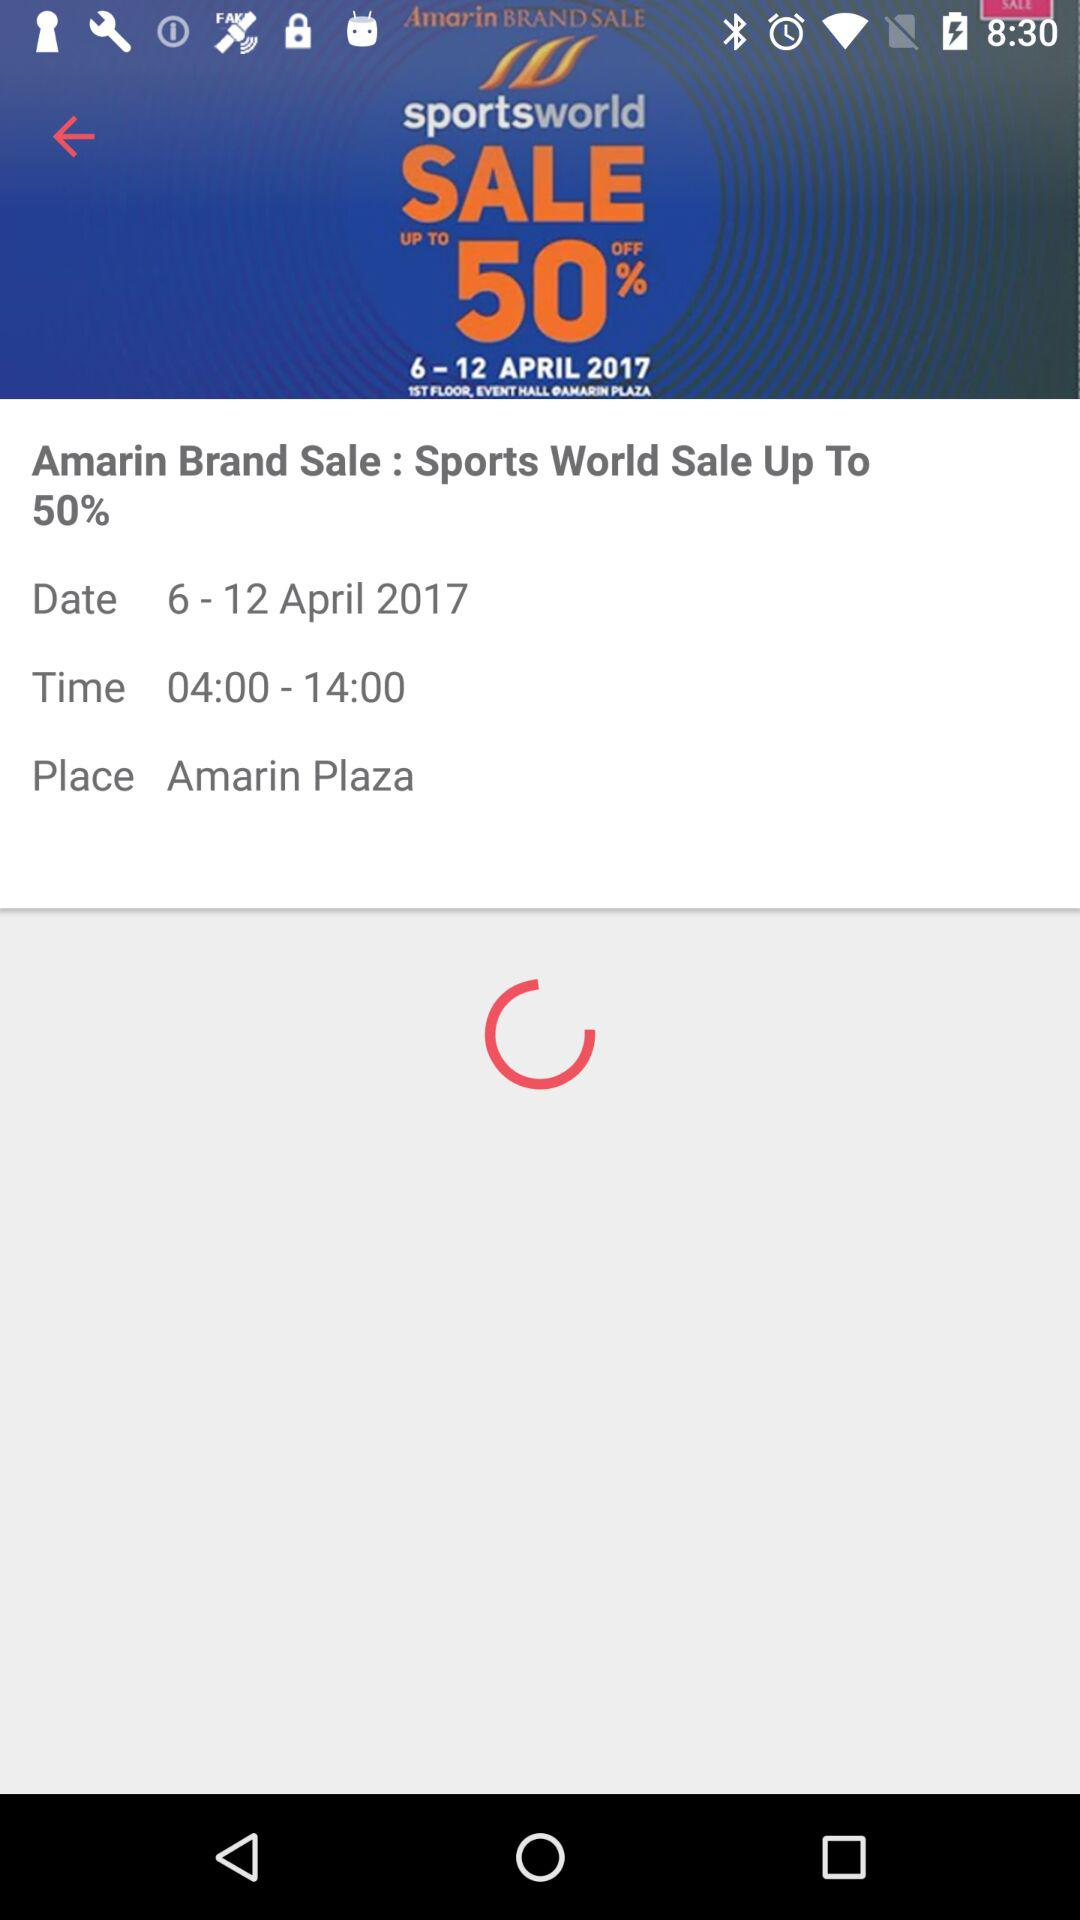At what time did the sale start? The sale started at 4:00. 